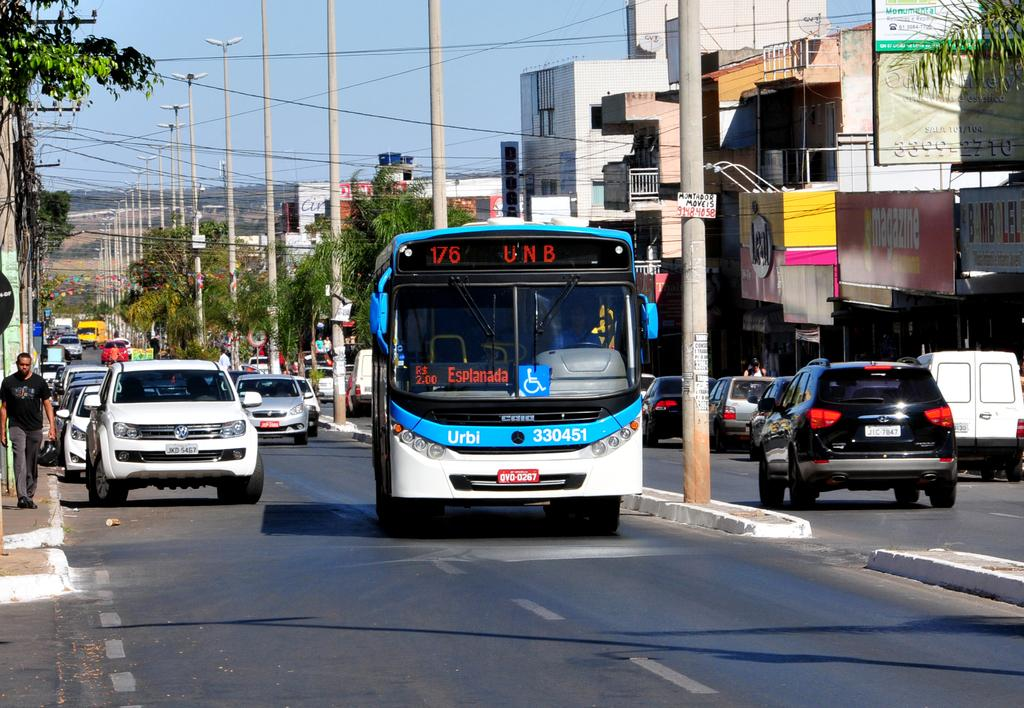What types of vehicles can be seen in the image? There are vehicles in the image, including a bus. Where are the vehicles and bus located? The vehicles and bus are on a road in the image. What else can be seen in the image besides the vehicles and bus? There are poles, wires, trees, buildings, and the sky visible in the image. What type of twig is being used as a support for the belief system in the image? There is no mention of a belief system or a twig in the image; it primarily features vehicles, a bus, and other urban elements. 